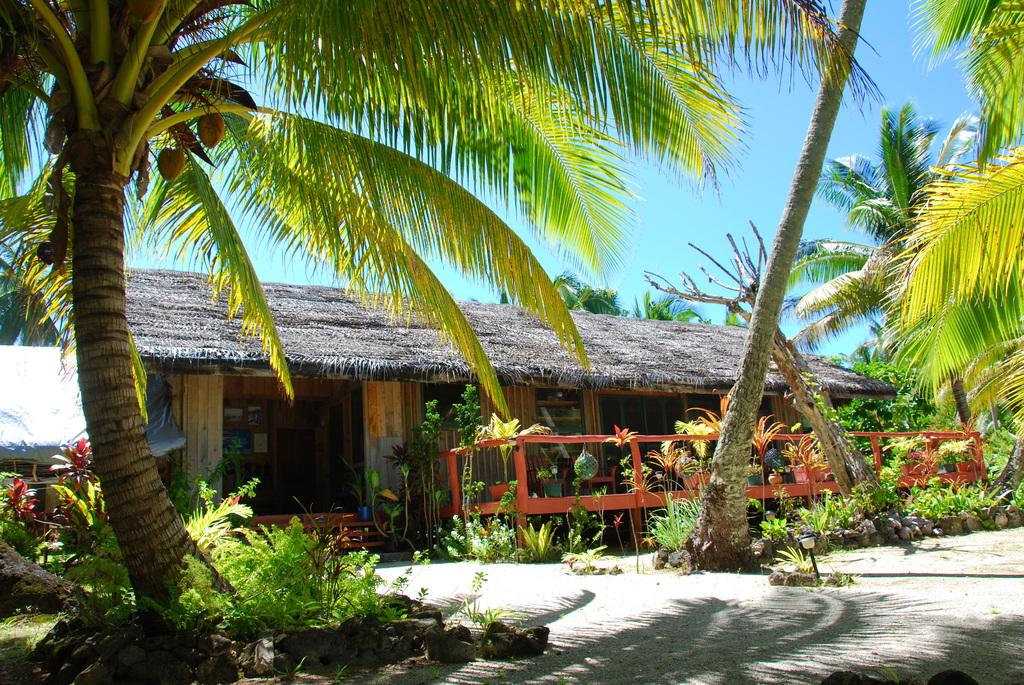What type of vegetation can be seen in the image? There are trees and plants in the image. What is the source of light visible in the image? The light visible in the image could be from the sun or artificial sources. What type of barrier is present in the image? There is a fence in the image. What type of structure is present in the image? There is a house in the image. What can be seen in the background of the image? There are trees and the blue sky visible in the background of the image. What advice is the tree giving to the plants in the image? There is no indication in the image that the tree is giving advice to the plants. Can you see any veins in the image? There are no veins visible in the image, as it features trees, plants, a fence, a house, and the sky. 